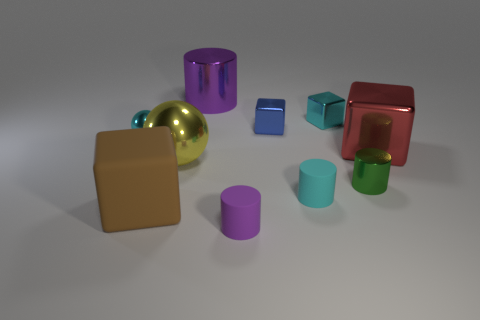Subtract all purple balls. Subtract all gray blocks. How many balls are left? 2 Subtract all cylinders. How many objects are left? 6 Add 5 large yellow metallic objects. How many large yellow metallic objects exist? 6 Subtract 0 gray spheres. How many objects are left? 10 Subtract all tiny purple matte spheres. Subtract all small cyan metal balls. How many objects are left? 9 Add 4 large metallic blocks. How many large metallic blocks are left? 5 